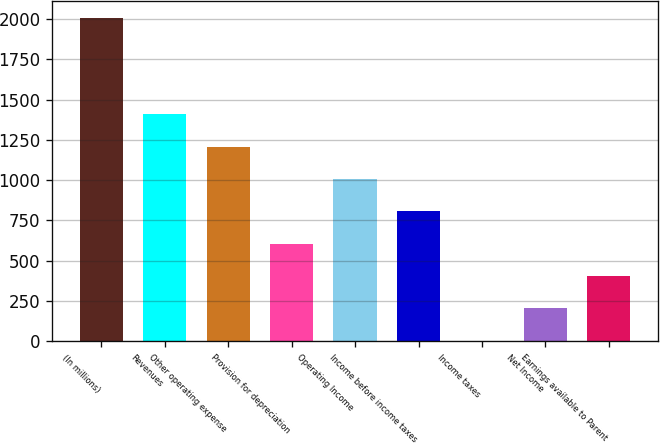Convert chart to OTSL. <chart><loc_0><loc_0><loc_500><loc_500><bar_chart><fcel>(In millions)<fcel>Revenues<fcel>Other operating expense<fcel>Provision for depreciation<fcel>Operating Income<fcel>Income before income taxes<fcel>Income taxes<fcel>Net Income<fcel>Earnings available to Parent<nl><fcel>2010<fcel>1408.32<fcel>1207.76<fcel>606.08<fcel>1007.2<fcel>806.64<fcel>4.4<fcel>204.96<fcel>405.52<nl></chart> 